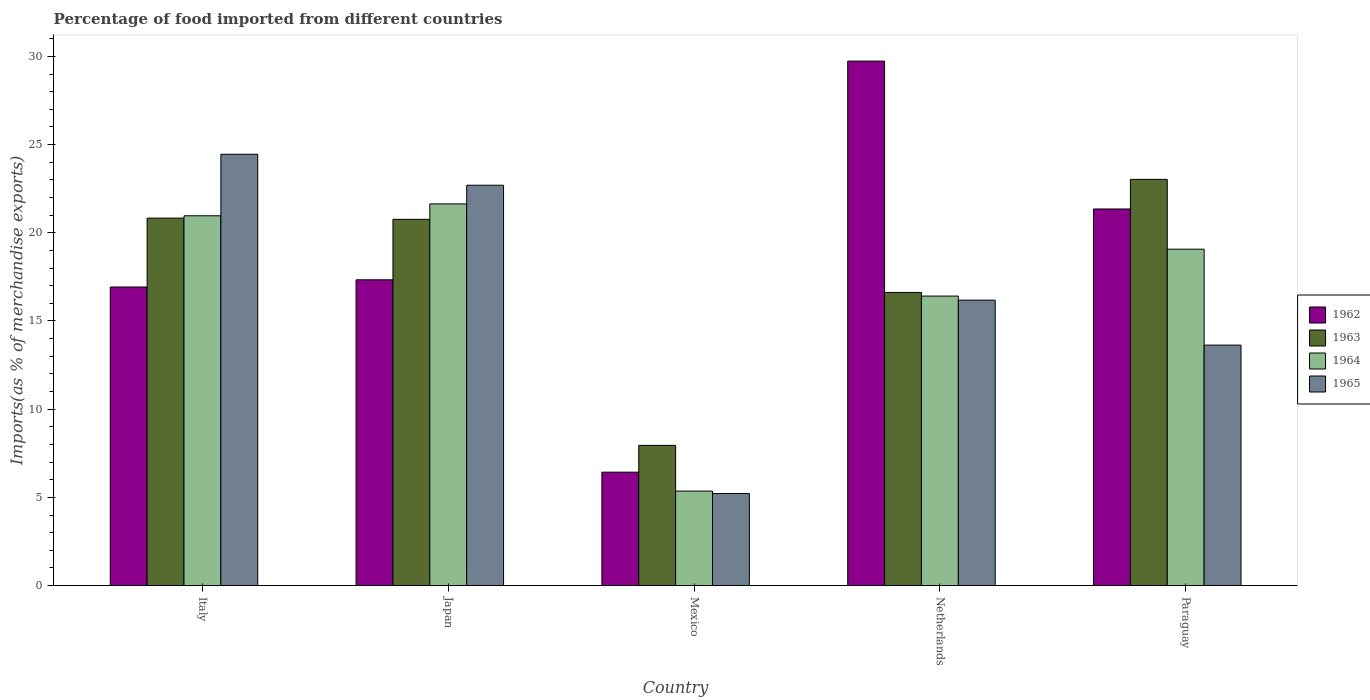How many different coloured bars are there?
Ensure brevity in your answer.  4. How many groups of bars are there?
Keep it short and to the point. 5. Are the number of bars on each tick of the X-axis equal?
Give a very brief answer. Yes. What is the label of the 4th group of bars from the left?
Keep it short and to the point. Netherlands. In how many cases, is the number of bars for a given country not equal to the number of legend labels?
Make the answer very short. 0. What is the percentage of imports to different countries in 1964 in Mexico?
Your answer should be compact. 5.36. Across all countries, what is the maximum percentage of imports to different countries in 1964?
Make the answer very short. 21.64. Across all countries, what is the minimum percentage of imports to different countries in 1965?
Your response must be concise. 5.22. In which country was the percentage of imports to different countries in 1963 maximum?
Make the answer very short. Paraguay. In which country was the percentage of imports to different countries in 1963 minimum?
Your answer should be compact. Mexico. What is the total percentage of imports to different countries in 1964 in the graph?
Your answer should be very brief. 83.44. What is the difference between the percentage of imports to different countries in 1965 in Japan and that in Netherlands?
Your answer should be very brief. 6.51. What is the difference between the percentage of imports to different countries in 1965 in Netherlands and the percentage of imports to different countries in 1962 in Paraguay?
Keep it short and to the point. -5.17. What is the average percentage of imports to different countries in 1964 per country?
Your answer should be compact. 16.69. What is the difference between the percentage of imports to different countries of/in 1963 and percentage of imports to different countries of/in 1962 in Japan?
Offer a terse response. 3.43. What is the ratio of the percentage of imports to different countries in 1965 in Italy to that in Paraguay?
Your answer should be very brief. 1.79. What is the difference between the highest and the second highest percentage of imports to different countries in 1963?
Your response must be concise. 0.07. What is the difference between the highest and the lowest percentage of imports to different countries in 1965?
Provide a succinct answer. 19.24. Is the sum of the percentage of imports to different countries in 1962 in Italy and Netherlands greater than the maximum percentage of imports to different countries in 1964 across all countries?
Provide a succinct answer. Yes. What does the 4th bar from the left in Mexico represents?
Your response must be concise. 1965. What does the 1st bar from the right in Netherlands represents?
Provide a succinct answer. 1965. Is it the case that in every country, the sum of the percentage of imports to different countries in 1963 and percentage of imports to different countries in 1965 is greater than the percentage of imports to different countries in 1964?
Give a very brief answer. Yes. How many bars are there?
Provide a short and direct response. 20. What is the difference between two consecutive major ticks on the Y-axis?
Your answer should be compact. 5. Are the values on the major ticks of Y-axis written in scientific E-notation?
Make the answer very short. No. Where does the legend appear in the graph?
Make the answer very short. Center right. How are the legend labels stacked?
Provide a succinct answer. Vertical. What is the title of the graph?
Keep it short and to the point. Percentage of food imported from different countries. Does "2012" appear as one of the legend labels in the graph?
Your response must be concise. No. What is the label or title of the Y-axis?
Ensure brevity in your answer.  Imports(as % of merchandise exports). What is the Imports(as % of merchandise exports) in 1962 in Italy?
Keep it short and to the point. 16.93. What is the Imports(as % of merchandise exports) of 1963 in Italy?
Your answer should be very brief. 20.83. What is the Imports(as % of merchandise exports) of 1964 in Italy?
Provide a short and direct response. 20.97. What is the Imports(as % of merchandise exports) of 1965 in Italy?
Make the answer very short. 24.45. What is the Imports(as % of merchandise exports) of 1962 in Japan?
Provide a succinct answer. 17.34. What is the Imports(as % of merchandise exports) of 1963 in Japan?
Give a very brief answer. 20.76. What is the Imports(as % of merchandise exports) in 1964 in Japan?
Keep it short and to the point. 21.64. What is the Imports(as % of merchandise exports) in 1965 in Japan?
Keep it short and to the point. 22.7. What is the Imports(as % of merchandise exports) of 1962 in Mexico?
Make the answer very short. 6.43. What is the Imports(as % of merchandise exports) in 1963 in Mexico?
Give a very brief answer. 7.95. What is the Imports(as % of merchandise exports) in 1964 in Mexico?
Your answer should be very brief. 5.36. What is the Imports(as % of merchandise exports) of 1965 in Mexico?
Offer a terse response. 5.22. What is the Imports(as % of merchandise exports) in 1962 in Netherlands?
Your answer should be very brief. 29.73. What is the Imports(as % of merchandise exports) in 1963 in Netherlands?
Your response must be concise. 16.62. What is the Imports(as % of merchandise exports) of 1964 in Netherlands?
Offer a terse response. 16.41. What is the Imports(as % of merchandise exports) in 1965 in Netherlands?
Your response must be concise. 16.18. What is the Imports(as % of merchandise exports) of 1962 in Paraguay?
Ensure brevity in your answer.  21.35. What is the Imports(as % of merchandise exports) in 1963 in Paraguay?
Make the answer very short. 23.03. What is the Imports(as % of merchandise exports) of 1964 in Paraguay?
Your response must be concise. 19.07. What is the Imports(as % of merchandise exports) in 1965 in Paraguay?
Offer a very short reply. 13.63. Across all countries, what is the maximum Imports(as % of merchandise exports) in 1962?
Give a very brief answer. 29.73. Across all countries, what is the maximum Imports(as % of merchandise exports) in 1963?
Your answer should be very brief. 23.03. Across all countries, what is the maximum Imports(as % of merchandise exports) in 1964?
Give a very brief answer. 21.64. Across all countries, what is the maximum Imports(as % of merchandise exports) of 1965?
Offer a very short reply. 24.45. Across all countries, what is the minimum Imports(as % of merchandise exports) of 1962?
Your answer should be very brief. 6.43. Across all countries, what is the minimum Imports(as % of merchandise exports) of 1963?
Offer a very short reply. 7.95. Across all countries, what is the minimum Imports(as % of merchandise exports) of 1964?
Make the answer very short. 5.36. Across all countries, what is the minimum Imports(as % of merchandise exports) in 1965?
Offer a very short reply. 5.22. What is the total Imports(as % of merchandise exports) of 1962 in the graph?
Your answer should be very brief. 91.78. What is the total Imports(as % of merchandise exports) of 1963 in the graph?
Your answer should be compact. 89.19. What is the total Imports(as % of merchandise exports) of 1964 in the graph?
Your answer should be very brief. 83.44. What is the total Imports(as % of merchandise exports) in 1965 in the graph?
Make the answer very short. 82.18. What is the difference between the Imports(as % of merchandise exports) in 1962 in Italy and that in Japan?
Your answer should be very brief. -0.41. What is the difference between the Imports(as % of merchandise exports) in 1963 in Italy and that in Japan?
Your answer should be very brief. 0.07. What is the difference between the Imports(as % of merchandise exports) in 1964 in Italy and that in Japan?
Your answer should be compact. -0.67. What is the difference between the Imports(as % of merchandise exports) of 1965 in Italy and that in Japan?
Make the answer very short. 1.76. What is the difference between the Imports(as % of merchandise exports) of 1962 in Italy and that in Mexico?
Make the answer very short. 10.5. What is the difference between the Imports(as % of merchandise exports) of 1963 in Italy and that in Mexico?
Keep it short and to the point. 12.88. What is the difference between the Imports(as % of merchandise exports) of 1964 in Italy and that in Mexico?
Your response must be concise. 15.61. What is the difference between the Imports(as % of merchandise exports) of 1965 in Italy and that in Mexico?
Your answer should be compact. 19.24. What is the difference between the Imports(as % of merchandise exports) in 1962 in Italy and that in Netherlands?
Your response must be concise. -12.81. What is the difference between the Imports(as % of merchandise exports) of 1963 in Italy and that in Netherlands?
Make the answer very short. 4.21. What is the difference between the Imports(as % of merchandise exports) in 1964 in Italy and that in Netherlands?
Your answer should be compact. 4.55. What is the difference between the Imports(as % of merchandise exports) in 1965 in Italy and that in Netherlands?
Ensure brevity in your answer.  8.27. What is the difference between the Imports(as % of merchandise exports) of 1962 in Italy and that in Paraguay?
Ensure brevity in your answer.  -4.42. What is the difference between the Imports(as % of merchandise exports) of 1963 in Italy and that in Paraguay?
Keep it short and to the point. -2.2. What is the difference between the Imports(as % of merchandise exports) in 1964 in Italy and that in Paraguay?
Make the answer very short. 1.89. What is the difference between the Imports(as % of merchandise exports) in 1965 in Italy and that in Paraguay?
Your response must be concise. 10.82. What is the difference between the Imports(as % of merchandise exports) in 1962 in Japan and that in Mexico?
Your response must be concise. 10.91. What is the difference between the Imports(as % of merchandise exports) in 1963 in Japan and that in Mexico?
Your response must be concise. 12.82. What is the difference between the Imports(as % of merchandise exports) of 1964 in Japan and that in Mexico?
Make the answer very short. 16.28. What is the difference between the Imports(as % of merchandise exports) of 1965 in Japan and that in Mexico?
Offer a terse response. 17.48. What is the difference between the Imports(as % of merchandise exports) in 1962 in Japan and that in Netherlands?
Keep it short and to the point. -12.4. What is the difference between the Imports(as % of merchandise exports) of 1963 in Japan and that in Netherlands?
Ensure brevity in your answer.  4.15. What is the difference between the Imports(as % of merchandise exports) of 1964 in Japan and that in Netherlands?
Give a very brief answer. 5.23. What is the difference between the Imports(as % of merchandise exports) in 1965 in Japan and that in Netherlands?
Keep it short and to the point. 6.51. What is the difference between the Imports(as % of merchandise exports) of 1962 in Japan and that in Paraguay?
Provide a succinct answer. -4.02. What is the difference between the Imports(as % of merchandise exports) in 1963 in Japan and that in Paraguay?
Your response must be concise. -2.26. What is the difference between the Imports(as % of merchandise exports) of 1964 in Japan and that in Paraguay?
Ensure brevity in your answer.  2.57. What is the difference between the Imports(as % of merchandise exports) in 1965 in Japan and that in Paraguay?
Give a very brief answer. 9.06. What is the difference between the Imports(as % of merchandise exports) of 1962 in Mexico and that in Netherlands?
Give a very brief answer. -23.31. What is the difference between the Imports(as % of merchandise exports) in 1963 in Mexico and that in Netherlands?
Offer a very short reply. -8.67. What is the difference between the Imports(as % of merchandise exports) of 1964 in Mexico and that in Netherlands?
Give a very brief answer. -11.05. What is the difference between the Imports(as % of merchandise exports) in 1965 in Mexico and that in Netherlands?
Keep it short and to the point. -10.97. What is the difference between the Imports(as % of merchandise exports) in 1962 in Mexico and that in Paraguay?
Give a very brief answer. -14.92. What is the difference between the Imports(as % of merchandise exports) in 1963 in Mexico and that in Paraguay?
Your response must be concise. -15.08. What is the difference between the Imports(as % of merchandise exports) in 1964 in Mexico and that in Paraguay?
Offer a terse response. -13.71. What is the difference between the Imports(as % of merchandise exports) of 1965 in Mexico and that in Paraguay?
Ensure brevity in your answer.  -8.42. What is the difference between the Imports(as % of merchandise exports) of 1962 in Netherlands and that in Paraguay?
Your response must be concise. 8.38. What is the difference between the Imports(as % of merchandise exports) in 1963 in Netherlands and that in Paraguay?
Make the answer very short. -6.41. What is the difference between the Imports(as % of merchandise exports) of 1964 in Netherlands and that in Paraguay?
Provide a succinct answer. -2.66. What is the difference between the Imports(as % of merchandise exports) of 1965 in Netherlands and that in Paraguay?
Offer a terse response. 2.55. What is the difference between the Imports(as % of merchandise exports) in 1962 in Italy and the Imports(as % of merchandise exports) in 1963 in Japan?
Provide a succinct answer. -3.84. What is the difference between the Imports(as % of merchandise exports) of 1962 in Italy and the Imports(as % of merchandise exports) of 1964 in Japan?
Make the answer very short. -4.71. What is the difference between the Imports(as % of merchandise exports) of 1962 in Italy and the Imports(as % of merchandise exports) of 1965 in Japan?
Offer a very short reply. -5.77. What is the difference between the Imports(as % of merchandise exports) of 1963 in Italy and the Imports(as % of merchandise exports) of 1964 in Japan?
Ensure brevity in your answer.  -0.81. What is the difference between the Imports(as % of merchandise exports) of 1963 in Italy and the Imports(as % of merchandise exports) of 1965 in Japan?
Offer a very short reply. -1.86. What is the difference between the Imports(as % of merchandise exports) of 1964 in Italy and the Imports(as % of merchandise exports) of 1965 in Japan?
Make the answer very short. -1.73. What is the difference between the Imports(as % of merchandise exports) of 1962 in Italy and the Imports(as % of merchandise exports) of 1963 in Mexico?
Your response must be concise. 8.98. What is the difference between the Imports(as % of merchandise exports) of 1962 in Italy and the Imports(as % of merchandise exports) of 1964 in Mexico?
Offer a terse response. 11.57. What is the difference between the Imports(as % of merchandise exports) of 1962 in Italy and the Imports(as % of merchandise exports) of 1965 in Mexico?
Your response must be concise. 11.71. What is the difference between the Imports(as % of merchandise exports) of 1963 in Italy and the Imports(as % of merchandise exports) of 1964 in Mexico?
Keep it short and to the point. 15.48. What is the difference between the Imports(as % of merchandise exports) in 1963 in Italy and the Imports(as % of merchandise exports) in 1965 in Mexico?
Make the answer very short. 15.62. What is the difference between the Imports(as % of merchandise exports) in 1964 in Italy and the Imports(as % of merchandise exports) in 1965 in Mexico?
Give a very brief answer. 15.75. What is the difference between the Imports(as % of merchandise exports) in 1962 in Italy and the Imports(as % of merchandise exports) in 1963 in Netherlands?
Keep it short and to the point. 0.31. What is the difference between the Imports(as % of merchandise exports) of 1962 in Italy and the Imports(as % of merchandise exports) of 1964 in Netherlands?
Keep it short and to the point. 0.51. What is the difference between the Imports(as % of merchandise exports) of 1962 in Italy and the Imports(as % of merchandise exports) of 1965 in Netherlands?
Provide a short and direct response. 0.74. What is the difference between the Imports(as % of merchandise exports) of 1963 in Italy and the Imports(as % of merchandise exports) of 1964 in Netherlands?
Your response must be concise. 4.42. What is the difference between the Imports(as % of merchandise exports) of 1963 in Italy and the Imports(as % of merchandise exports) of 1965 in Netherlands?
Your response must be concise. 4.65. What is the difference between the Imports(as % of merchandise exports) of 1964 in Italy and the Imports(as % of merchandise exports) of 1965 in Netherlands?
Provide a succinct answer. 4.78. What is the difference between the Imports(as % of merchandise exports) of 1962 in Italy and the Imports(as % of merchandise exports) of 1963 in Paraguay?
Provide a short and direct response. -6.1. What is the difference between the Imports(as % of merchandise exports) in 1962 in Italy and the Imports(as % of merchandise exports) in 1964 in Paraguay?
Provide a succinct answer. -2.14. What is the difference between the Imports(as % of merchandise exports) of 1962 in Italy and the Imports(as % of merchandise exports) of 1965 in Paraguay?
Your answer should be very brief. 3.29. What is the difference between the Imports(as % of merchandise exports) in 1963 in Italy and the Imports(as % of merchandise exports) in 1964 in Paraguay?
Your response must be concise. 1.76. What is the difference between the Imports(as % of merchandise exports) in 1963 in Italy and the Imports(as % of merchandise exports) in 1965 in Paraguay?
Give a very brief answer. 7.2. What is the difference between the Imports(as % of merchandise exports) of 1964 in Italy and the Imports(as % of merchandise exports) of 1965 in Paraguay?
Provide a succinct answer. 7.33. What is the difference between the Imports(as % of merchandise exports) of 1962 in Japan and the Imports(as % of merchandise exports) of 1963 in Mexico?
Ensure brevity in your answer.  9.39. What is the difference between the Imports(as % of merchandise exports) of 1962 in Japan and the Imports(as % of merchandise exports) of 1964 in Mexico?
Offer a very short reply. 11.98. What is the difference between the Imports(as % of merchandise exports) of 1962 in Japan and the Imports(as % of merchandise exports) of 1965 in Mexico?
Ensure brevity in your answer.  12.12. What is the difference between the Imports(as % of merchandise exports) of 1963 in Japan and the Imports(as % of merchandise exports) of 1964 in Mexico?
Ensure brevity in your answer.  15.41. What is the difference between the Imports(as % of merchandise exports) of 1963 in Japan and the Imports(as % of merchandise exports) of 1965 in Mexico?
Offer a terse response. 15.55. What is the difference between the Imports(as % of merchandise exports) of 1964 in Japan and the Imports(as % of merchandise exports) of 1965 in Mexico?
Provide a short and direct response. 16.42. What is the difference between the Imports(as % of merchandise exports) of 1962 in Japan and the Imports(as % of merchandise exports) of 1963 in Netherlands?
Give a very brief answer. 0.72. What is the difference between the Imports(as % of merchandise exports) of 1962 in Japan and the Imports(as % of merchandise exports) of 1964 in Netherlands?
Your answer should be compact. 0.92. What is the difference between the Imports(as % of merchandise exports) in 1962 in Japan and the Imports(as % of merchandise exports) in 1965 in Netherlands?
Offer a very short reply. 1.15. What is the difference between the Imports(as % of merchandise exports) of 1963 in Japan and the Imports(as % of merchandise exports) of 1964 in Netherlands?
Your answer should be very brief. 4.35. What is the difference between the Imports(as % of merchandise exports) in 1963 in Japan and the Imports(as % of merchandise exports) in 1965 in Netherlands?
Your answer should be very brief. 4.58. What is the difference between the Imports(as % of merchandise exports) in 1964 in Japan and the Imports(as % of merchandise exports) in 1965 in Netherlands?
Provide a succinct answer. 5.46. What is the difference between the Imports(as % of merchandise exports) in 1962 in Japan and the Imports(as % of merchandise exports) in 1963 in Paraguay?
Make the answer very short. -5.69. What is the difference between the Imports(as % of merchandise exports) in 1962 in Japan and the Imports(as % of merchandise exports) in 1964 in Paraguay?
Your answer should be compact. -1.74. What is the difference between the Imports(as % of merchandise exports) of 1962 in Japan and the Imports(as % of merchandise exports) of 1965 in Paraguay?
Make the answer very short. 3.7. What is the difference between the Imports(as % of merchandise exports) in 1963 in Japan and the Imports(as % of merchandise exports) in 1964 in Paraguay?
Provide a short and direct response. 1.69. What is the difference between the Imports(as % of merchandise exports) of 1963 in Japan and the Imports(as % of merchandise exports) of 1965 in Paraguay?
Offer a very short reply. 7.13. What is the difference between the Imports(as % of merchandise exports) of 1964 in Japan and the Imports(as % of merchandise exports) of 1965 in Paraguay?
Offer a very short reply. 8.01. What is the difference between the Imports(as % of merchandise exports) in 1962 in Mexico and the Imports(as % of merchandise exports) in 1963 in Netherlands?
Keep it short and to the point. -10.19. What is the difference between the Imports(as % of merchandise exports) of 1962 in Mexico and the Imports(as % of merchandise exports) of 1964 in Netherlands?
Give a very brief answer. -9.98. What is the difference between the Imports(as % of merchandise exports) of 1962 in Mexico and the Imports(as % of merchandise exports) of 1965 in Netherlands?
Offer a very short reply. -9.75. What is the difference between the Imports(as % of merchandise exports) in 1963 in Mexico and the Imports(as % of merchandise exports) in 1964 in Netherlands?
Provide a short and direct response. -8.46. What is the difference between the Imports(as % of merchandise exports) of 1963 in Mexico and the Imports(as % of merchandise exports) of 1965 in Netherlands?
Your answer should be compact. -8.23. What is the difference between the Imports(as % of merchandise exports) of 1964 in Mexico and the Imports(as % of merchandise exports) of 1965 in Netherlands?
Your response must be concise. -10.83. What is the difference between the Imports(as % of merchandise exports) in 1962 in Mexico and the Imports(as % of merchandise exports) in 1963 in Paraguay?
Keep it short and to the point. -16.6. What is the difference between the Imports(as % of merchandise exports) of 1962 in Mexico and the Imports(as % of merchandise exports) of 1964 in Paraguay?
Provide a succinct answer. -12.64. What is the difference between the Imports(as % of merchandise exports) in 1962 in Mexico and the Imports(as % of merchandise exports) in 1965 in Paraguay?
Offer a terse response. -7.2. What is the difference between the Imports(as % of merchandise exports) of 1963 in Mexico and the Imports(as % of merchandise exports) of 1964 in Paraguay?
Make the answer very short. -11.12. What is the difference between the Imports(as % of merchandise exports) of 1963 in Mexico and the Imports(as % of merchandise exports) of 1965 in Paraguay?
Make the answer very short. -5.68. What is the difference between the Imports(as % of merchandise exports) of 1964 in Mexico and the Imports(as % of merchandise exports) of 1965 in Paraguay?
Keep it short and to the point. -8.27. What is the difference between the Imports(as % of merchandise exports) of 1962 in Netherlands and the Imports(as % of merchandise exports) of 1963 in Paraguay?
Ensure brevity in your answer.  6.71. What is the difference between the Imports(as % of merchandise exports) in 1962 in Netherlands and the Imports(as % of merchandise exports) in 1964 in Paraguay?
Offer a very short reply. 10.66. What is the difference between the Imports(as % of merchandise exports) of 1962 in Netherlands and the Imports(as % of merchandise exports) of 1965 in Paraguay?
Ensure brevity in your answer.  16.1. What is the difference between the Imports(as % of merchandise exports) of 1963 in Netherlands and the Imports(as % of merchandise exports) of 1964 in Paraguay?
Your answer should be compact. -2.45. What is the difference between the Imports(as % of merchandise exports) of 1963 in Netherlands and the Imports(as % of merchandise exports) of 1965 in Paraguay?
Provide a short and direct response. 2.99. What is the difference between the Imports(as % of merchandise exports) in 1964 in Netherlands and the Imports(as % of merchandise exports) in 1965 in Paraguay?
Your response must be concise. 2.78. What is the average Imports(as % of merchandise exports) of 1962 per country?
Provide a succinct answer. 18.36. What is the average Imports(as % of merchandise exports) in 1963 per country?
Your answer should be compact. 17.84. What is the average Imports(as % of merchandise exports) in 1964 per country?
Keep it short and to the point. 16.69. What is the average Imports(as % of merchandise exports) in 1965 per country?
Provide a short and direct response. 16.44. What is the difference between the Imports(as % of merchandise exports) in 1962 and Imports(as % of merchandise exports) in 1963 in Italy?
Keep it short and to the point. -3.91. What is the difference between the Imports(as % of merchandise exports) of 1962 and Imports(as % of merchandise exports) of 1964 in Italy?
Your response must be concise. -4.04. What is the difference between the Imports(as % of merchandise exports) in 1962 and Imports(as % of merchandise exports) in 1965 in Italy?
Offer a very short reply. -7.53. What is the difference between the Imports(as % of merchandise exports) in 1963 and Imports(as % of merchandise exports) in 1964 in Italy?
Make the answer very short. -0.13. What is the difference between the Imports(as % of merchandise exports) of 1963 and Imports(as % of merchandise exports) of 1965 in Italy?
Offer a very short reply. -3.62. What is the difference between the Imports(as % of merchandise exports) in 1964 and Imports(as % of merchandise exports) in 1965 in Italy?
Your answer should be compact. -3.49. What is the difference between the Imports(as % of merchandise exports) of 1962 and Imports(as % of merchandise exports) of 1963 in Japan?
Your answer should be very brief. -3.43. What is the difference between the Imports(as % of merchandise exports) in 1962 and Imports(as % of merchandise exports) in 1964 in Japan?
Your answer should be very brief. -4.3. What is the difference between the Imports(as % of merchandise exports) of 1962 and Imports(as % of merchandise exports) of 1965 in Japan?
Your answer should be compact. -5.36. What is the difference between the Imports(as % of merchandise exports) of 1963 and Imports(as % of merchandise exports) of 1964 in Japan?
Ensure brevity in your answer.  -0.87. What is the difference between the Imports(as % of merchandise exports) in 1963 and Imports(as % of merchandise exports) in 1965 in Japan?
Provide a short and direct response. -1.93. What is the difference between the Imports(as % of merchandise exports) of 1964 and Imports(as % of merchandise exports) of 1965 in Japan?
Provide a short and direct response. -1.06. What is the difference between the Imports(as % of merchandise exports) of 1962 and Imports(as % of merchandise exports) of 1963 in Mexico?
Provide a short and direct response. -1.52. What is the difference between the Imports(as % of merchandise exports) in 1962 and Imports(as % of merchandise exports) in 1964 in Mexico?
Your response must be concise. 1.07. What is the difference between the Imports(as % of merchandise exports) in 1962 and Imports(as % of merchandise exports) in 1965 in Mexico?
Make the answer very short. 1.21. What is the difference between the Imports(as % of merchandise exports) of 1963 and Imports(as % of merchandise exports) of 1964 in Mexico?
Make the answer very short. 2.59. What is the difference between the Imports(as % of merchandise exports) of 1963 and Imports(as % of merchandise exports) of 1965 in Mexico?
Keep it short and to the point. 2.73. What is the difference between the Imports(as % of merchandise exports) in 1964 and Imports(as % of merchandise exports) in 1965 in Mexico?
Provide a succinct answer. 0.14. What is the difference between the Imports(as % of merchandise exports) in 1962 and Imports(as % of merchandise exports) in 1963 in Netherlands?
Offer a terse response. 13.12. What is the difference between the Imports(as % of merchandise exports) of 1962 and Imports(as % of merchandise exports) of 1964 in Netherlands?
Make the answer very short. 13.32. What is the difference between the Imports(as % of merchandise exports) in 1962 and Imports(as % of merchandise exports) in 1965 in Netherlands?
Keep it short and to the point. 13.55. What is the difference between the Imports(as % of merchandise exports) of 1963 and Imports(as % of merchandise exports) of 1964 in Netherlands?
Give a very brief answer. 0.21. What is the difference between the Imports(as % of merchandise exports) of 1963 and Imports(as % of merchandise exports) of 1965 in Netherlands?
Ensure brevity in your answer.  0.44. What is the difference between the Imports(as % of merchandise exports) of 1964 and Imports(as % of merchandise exports) of 1965 in Netherlands?
Your answer should be compact. 0.23. What is the difference between the Imports(as % of merchandise exports) of 1962 and Imports(as % of merchandise exports) of 1963 in Paraguay?
Your response must be concise. -1.68. What is the difference between the Imports(as % of merchandise exports) in 1962 and Imports(as % of merchandise exports) in 1964 in Paraguay?
Provide a short and direct response. 2.28. What is the difference between the Imports(as % of merchandise exports) of 1962 and Imports(as % of merchandise exports) of 1965 in Paraguay?
Your answer should be very brief. 7.72. What is the difference between the Imports(as % of merchandise exports) in 1963 and Imports(as % of merchandise exports) in 1964 in Paraguay?
Give a very brief answer. 3.96. What is the difference between the Imports(as % of merchandise exports) of 1963 and Imports(as % of merchandise exports) of 1965 in Paraguay?
Offer a terse response. 9.4. What is the difference between the Imports(as % of merchandise exports) of 1964 and Imports(as % of merchandise exports) of 1965 in Paraguay?
Your answer should be very brief. 5.44. What is the ratio of the Imports(as % of merchandise exports) of 1962 in Italy to that in Japan?
Provide a short and direct response. 0.98. What is the ratio of the Imports(as % of merchandise exports) of 1964 in Italy to that in Japan?
Your response must be concise. 0.97. What is the ratio of the Imports(as % of merchandise exports) in 1965 in Italy to that in Japan?
Provide a short and direct response. 1.08. What is the ratio of the Imports(as % of merchandise exports) of 1962 in Italy to that in Mexico?
Keep it short and to the point. 2.63. What is the ratio of the Imports(as % of merchandise exports) of 1963 in Italy to that in Mexico?
Ensure brevity in your answer.  2.62. What is the ratio of the Imports(as % of merchandise exports) of 1964 in Italy to that in Mexico?
Your answer should be compact. 3.91. What is the ratio of the Imports(as % of merchandise exports) in 1965 in Italy to that in Mexico?
Make the answer very short. 4.69. What is the ratio of the Imports(as % of merchandise exports) of 1962 in Italy to that in Netherlands?
Offer a very short reply. 0.57. What is the ratio of the Imports(as % of merchandise exports) in 1963 in Italy to that in Netherlands?
Ensure brevity in your answer.  1.25. What is the ratio of the Imports(as % of merchandise exports) of 1964 in Italy to that in Netherlands?
Provide a short and direct response. 1.28. What is the ratio of the Imports(as % of merchandise exports) in 1965 in Italy to that in Netherlands?
Give a very brief answer. 1.51. What is the ratio of the Imports(as % of merchandise exports) in 1962 in Italy to that in Paraguay?
Provide a succinct answer. 0.79. What is the ratio of the Imports(as % of merchandise exports) of 1963 in Italy to that in Paraguay?
Ensure brevity in your answer.  0.9. What is the ratio of the Imports(as % of merchandise exports) of 1964 in Italy to that in Paraguay?
Your response must be concise. 1.1. What is the ratio of the Imports(as % of merchandise exports) in 1965 in Italy to that in Paraguay?
Offer a very short reply. 1.79. What is the ratio of the Imports(as % of merchandise exports) of 1962 in Japan to that in Mexico?
Provide a succinct answer. 2.7. What is the ratio of the Imports(as % of merchandise exports) in 1963 in Japan to that in Mexico?
Your answer should be very brief. 2.61. What is the ratio of the Imports(as % of merchandise exports) in 1964 in Japan to that in Mexico?
Offer a very short reply. 4.04. What is the ratio of the Imports(as % of merchandise exports) in 1965 in Japan to that in Mexico?
Keep it short and to the point. 4.35. What is the ratio of the Imports(as % of merchandise exports) in 1962 in Japan to that in Netherlands?
Give a very brief answer. 0.58. What is the ratio of the Imports(as % of merchandise exports) in 1963 in Japan to that in Netherlands?
Offer a very short reply. 1.25. What is the ratio of the Imports(as % of merchandise exports) in 1964 in Japan to that in Netherlands?
Your answer should be compact. 1.32. What is the ratio of the Imports(as % of merchandise exports) in 1965 in Japan to that in Netherlands?
Your answer should be very brief. 1.4. What is the ratio of the Imports(as % of merchandise exports) of 1962 in Japan to that in Paraguay?
Keep it short and to the point. 0.81. What is the ratio of the Imports(as % of merchandise exports) in 1963 in Japan to that in Paraguay?
Ensure brevity in your answer.  0.9. What is the ratio of the Imports(as % of merchandise exports) of 1964 in Japan to that in Paraguay?
Provide a succinct answer. 1.13. What is the ratio of the Imports(as % of merchandise exports) in 1965 in Japan to that in Paraguay?
Offer a very short reply. 1.67. What is the ratio of the Imports(as % of merchandise exports) in 1962 in Mexico to that in Netherlands?
Offer a very short reply. 0.22. What is the ratio of the Imports(as % of merchandise exports) of 1963 in Mexico to that in Netherlands?
Provide a succinct answer. 0.48. What is the ratio of the Imports(as % of merchandise exports) in 1964 in Mexico to that in Netherlands?
Give a very brief answer. 0.33. What is the ratio of the Imports(as % of merchandise exports) of 1965 in Mexico to that in Netherlands?
Offer a terse response. 0.32. What is the ratio of the Imports(as % of merchandise exports) of 1962 in Mexico to that in Paraguay?
Keep it short and to the point. 0.3. What is the ratio of the Imports(as % of merchandise exports) in 1963 in Mexico to that in Paraguay?
Offer a terse response. 0.35. What is the ratio of the Imports(as % of merchandise exports) in 1964 in Mexico to that in Paraguay?
Ensure brevity in your answer.  0.28. What is the ratio of the Imports(as % of merchandise exports) in 1965 in Mexico to that in Paraguay?
Your answer should be very brief. 0.38. What is the ratio of the Imports(as % of merchandise exports) in 1962 in Netherlands to that in Paraguay?
Ensure brevity in your answer.  1.39. What is the ratio of the Imports(as % of merchandise exports) of 1963 in Netherlands to that in Paraguay?
Your answer should be very brief. 0.72. What is the ratio of the Imports(as % of merchandise exports) in 1964 in Netherlands to that in Paraguay?
Give a very brief answer. 0.86. What is the ratio of the Imports(as % of merchandise exports) in 1965 in Netherlands to that in Paraguay?
Offer a very short reply. 1.19. What is the difference between the highest and the second highest Imports(as % of merchandise exports) of 1962?
Give a very brief answer. 8.38. What is the difference between the highest and the second highest Imports(as % of merchandise exports) of 1963?
Provide a succinct answer. 2.2. What is the difference between the highest and the second highest Imports(as % of merchandise exports) in 1964?
Ensure brevity in your answer.  0.67. What is the difference between the highest and the second highest Imports(as % of merchandise exports) of 1965?
Offer a terse response. 1.76. What is the difference between the highest and the lowest Imports(as % of merchandise exports) of 1962?
Make the answer very short. 23.31. What is the difference between the highest and the lowest Imports(as % of merchandise exports) in 1963?
Give a very brief answer. 15.08. What is the difference between the highest and the lowest Imports(as % of merchandise exports) in 1964?
Ensure brevity in your answer.  16.28. What is the difference between the highest and the lowest Imports(as % of merchandise exports) in 1965?
Your answer should be very brief. 19.24. 